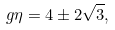<formula> <loc_0><loc_0><loc_500><loc_500>g \eta = 4 \pm 2 \sqrt { 3 } ,</formula> 